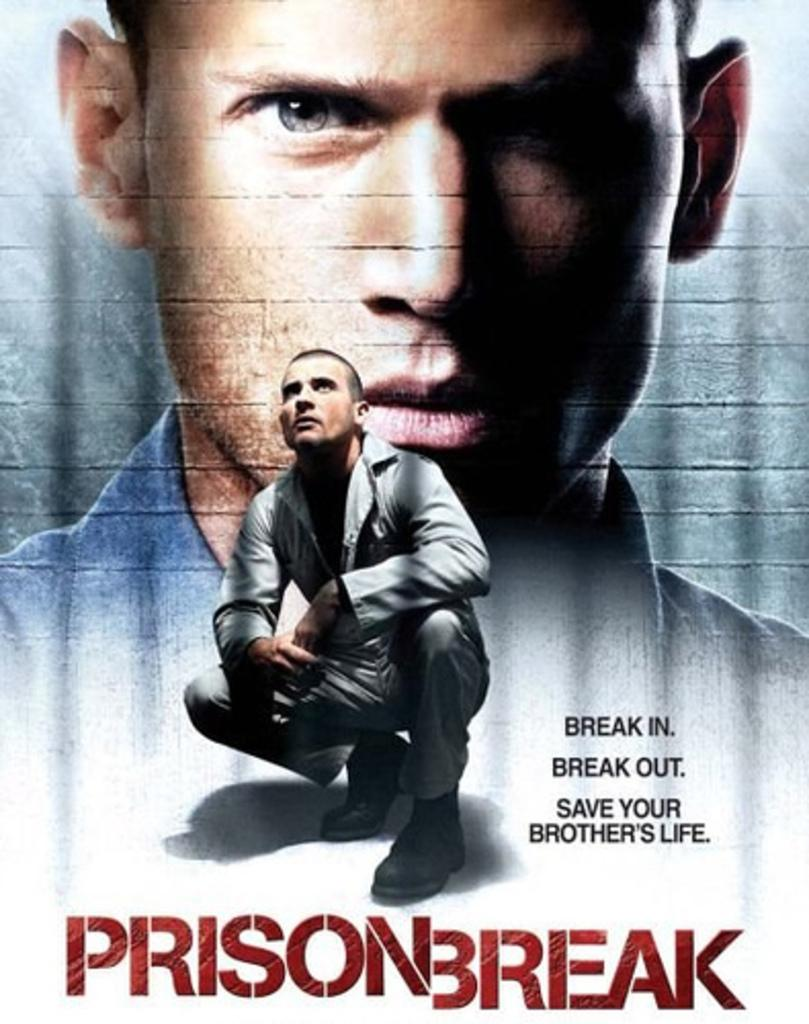<image>
Provide a brief description of the given image. An advertisement for the TV show Prison Break . 